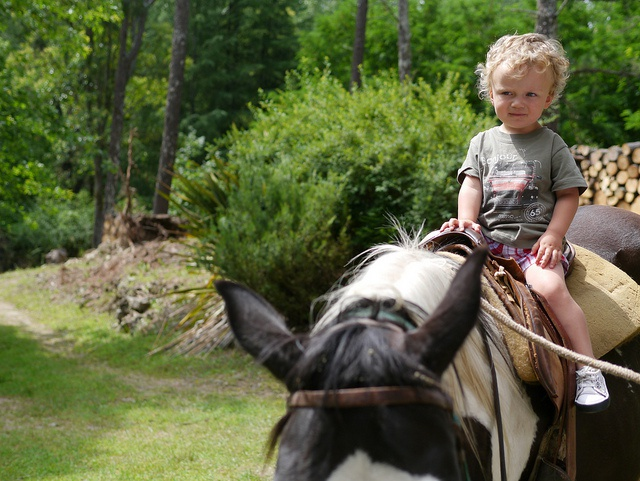Describe the objects in this image and their specific colors. I can see horse in darkgreen, black, gray, darkgray, and white tones and people in darkgreen, brown, lightgray, gray, and darkgray tones in this image. 